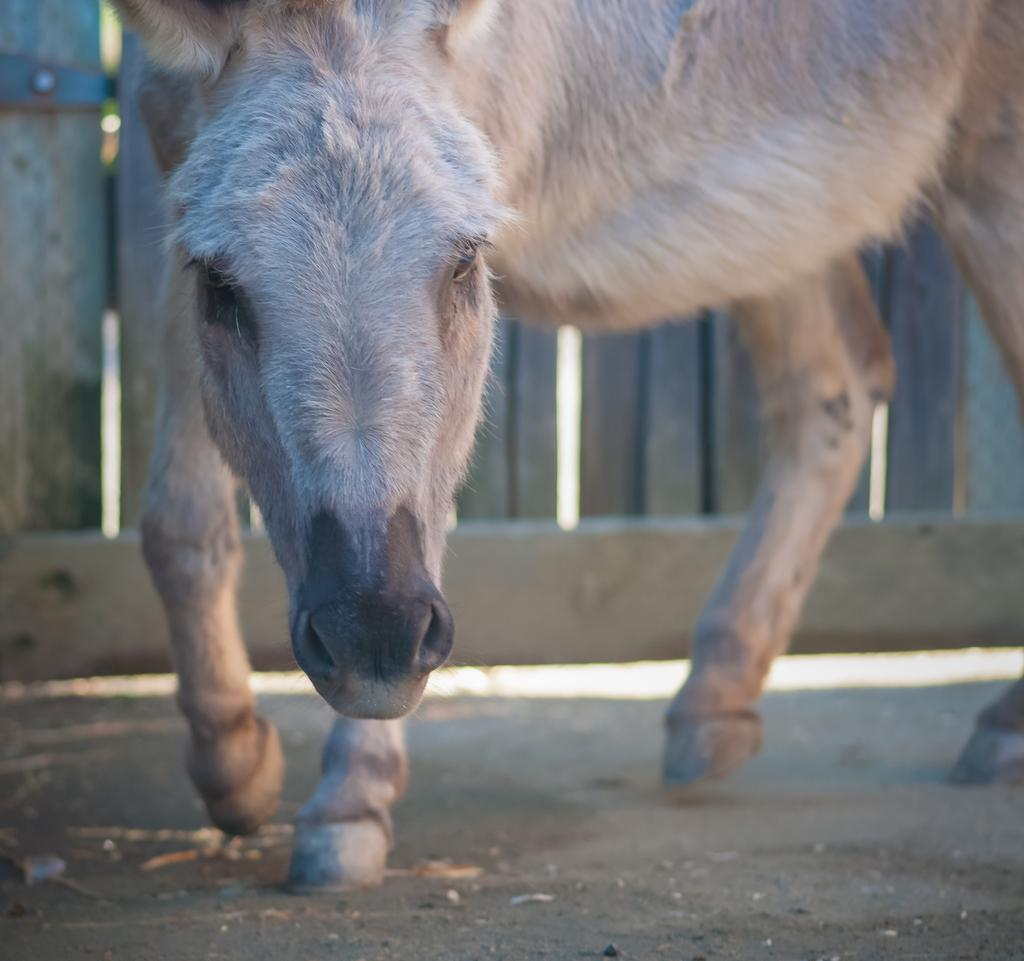What animal is present in the image? There is a horse in the image. What is the horse doing in the image? The horse is walking. How does the horse grip the body of the knot in the image? There is no knot present in the image, and horses do not have the ability to grip objects with their bodies. 